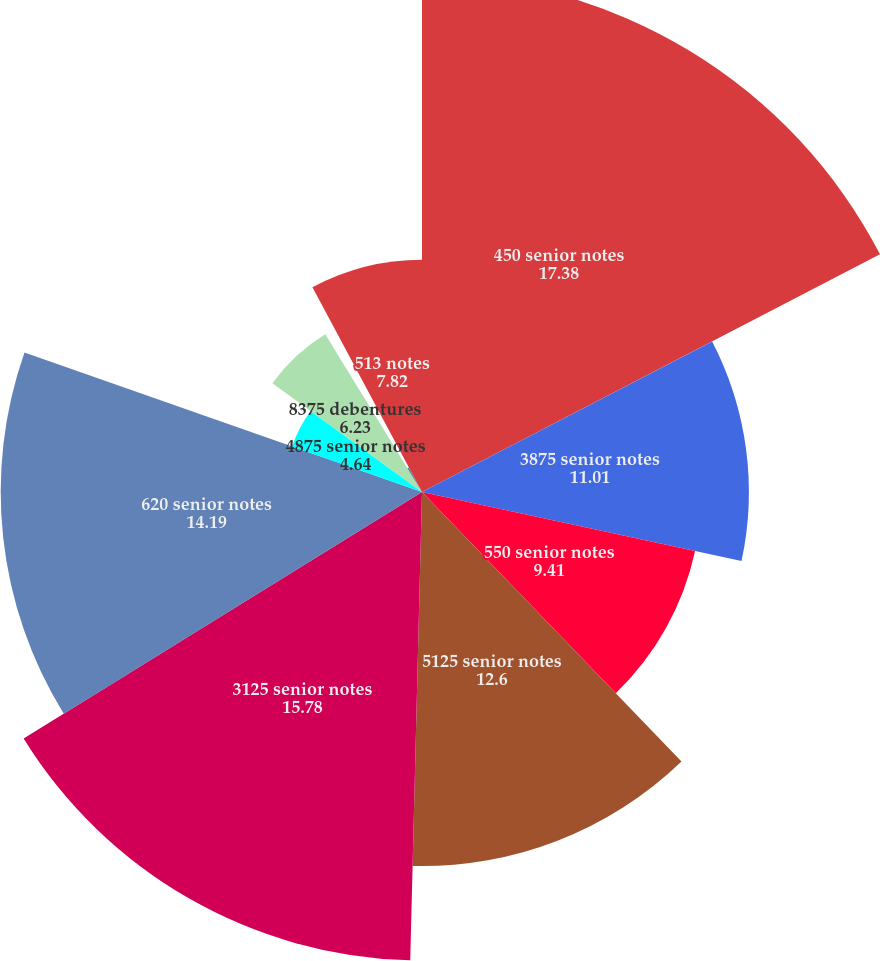<chart> <loc_0><loc_0><loc_500><loc_500><pie_chart><fcel>450 senior notes<fcel>3875 senior notes<fcel>550 senior notes<fcel>5125 senior notes<fcel>3125 senior notes<fcel>620 senior notes<fcel>4875 senior notes<fcel>8375 debentures<fcel>550 notes<fcel>513 notes<nl><fcel>17.38%<fcel>11.01%<fcel>9.41%<fcel>12.6%<fcel>15.78%<fcel>14.19%<fcel>4.64%<fcel>6.23%<fcel>0.94%<fcel>7.82%<nl></chart> 